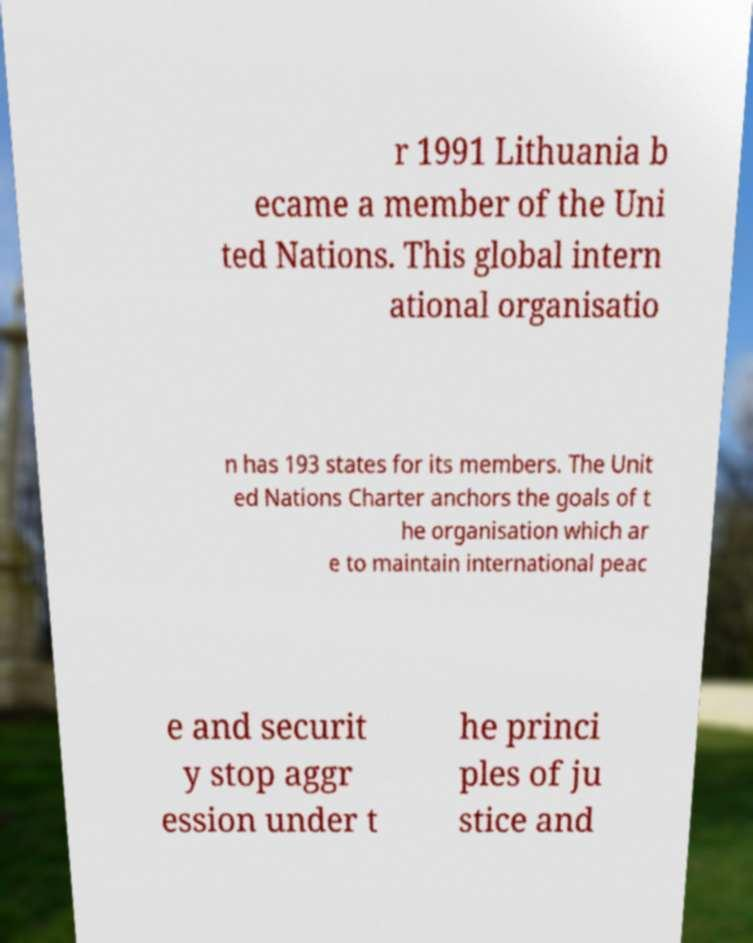What messages or text are displayed in this image? I need them in a readable, typed format. r 1991 Lithuania b ecame a member of the Uni ted Nations. This global intern ational organisatio n has 193 states for its members. The Unit ed Nations Charter anchors the goals of t he organisation which ar e to maintain international peac e and securit y stop aggr ession under t he princi ples of ju stice and 